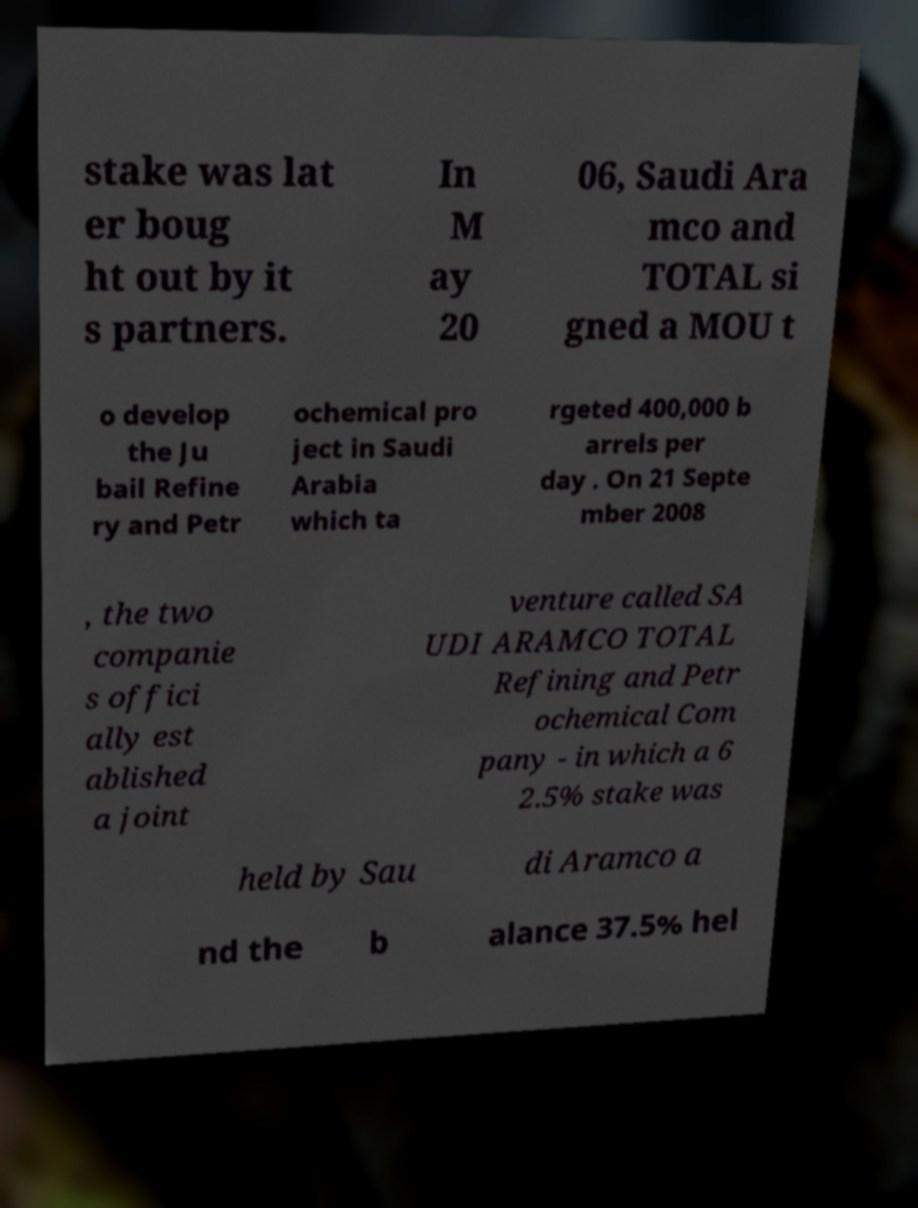Can you read and provide the text displayed in the image?This photo seems to have some interesting text. Can you extract and type it out for me? stake was lat er boug ht out by it s partners. In M ay 20 06, Saudi Ara mco and TOTAL si gned a MOU t o develop the Ju bail Refine ry and Petr ochemical pro ject in Saudi Arabia which ta rgeted 400,000 b arrels per day . On 21 Septe mber 2008 , the two companie s offici ally est ablished a joint venture called SA UDI ARAMCO TOTAL Refining and Petr ochemical Com pany - in which a 6 2.5% stake was held by Sau di Aramco a nd the b alance 37.5% hel 